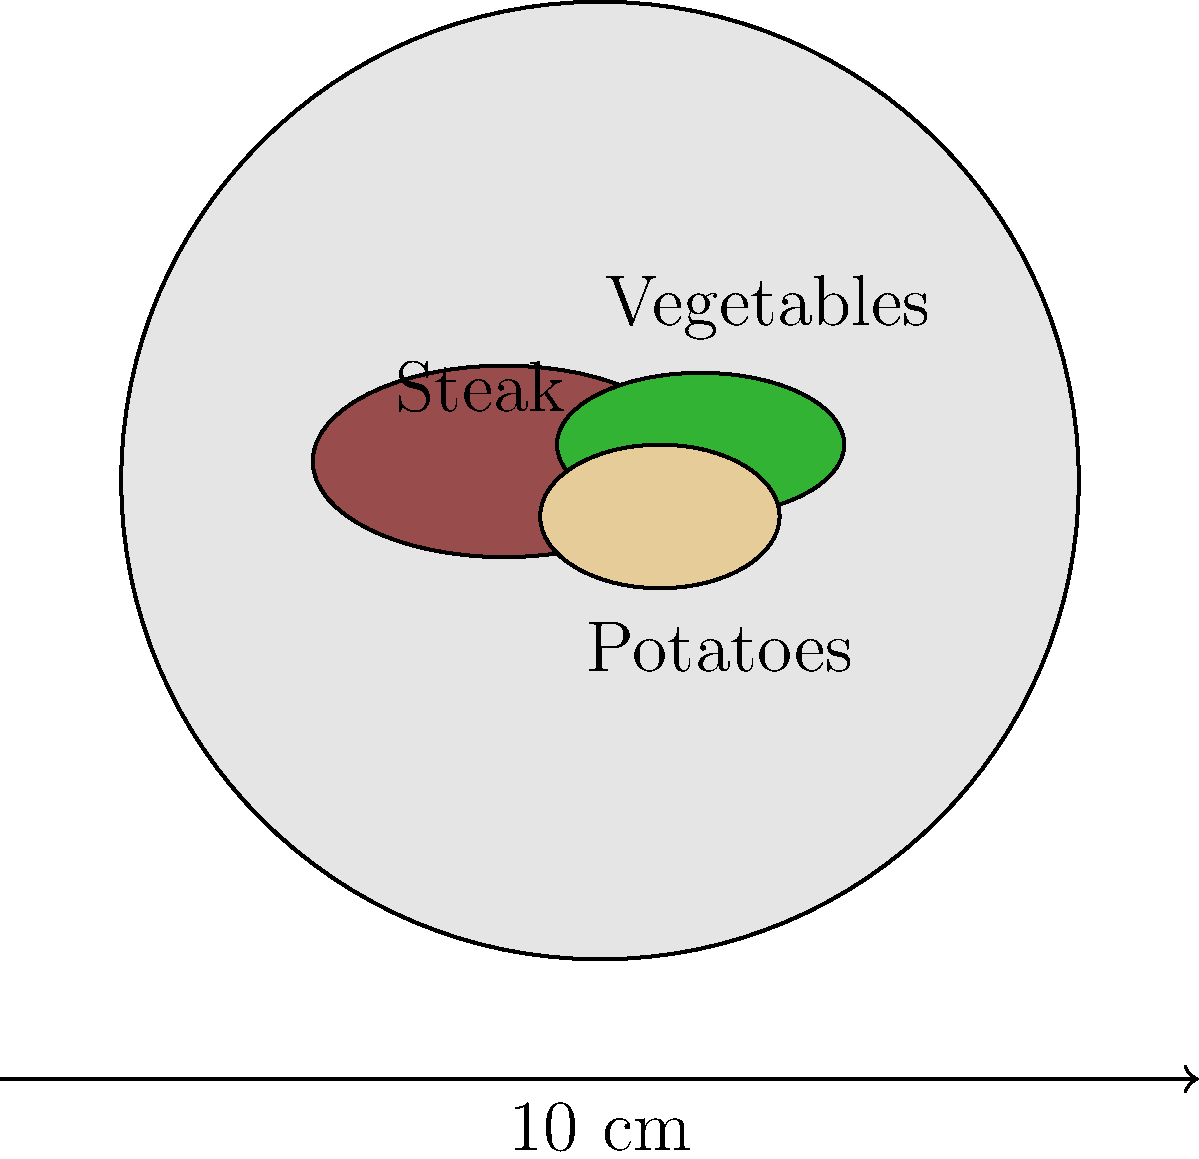As a chef, you're asked to estimate portion sizes from a photo of a plated meal. Given the image of a plate with a 10 cm diameter, estimate the approximate area (in cm²) occupied by the steak. Round your answer to the nearest whole number. To estimate the area occupied by the steak, we'll follow these steps:

1. Determine the scale of the image:
   The plate diameter is 10 cm, and in the image, it's about 4 units wide.
   So, 1 unit in the image = 10 cm / 4 = 2.5 cm in real life.

2. Estimate the dimensions of the steak:
   Length: Approximately 1.6 units * 2.5 cm/unit = 4 cm
   Width: Approximately 0.8 units * 2.5 cm/unit = 2 cm

3. Calculate the area of the steak:
   We can approximate the steak as an ellipse.
   Area of an ellipse = $\pi * a * b$, where $a$ and $b$ are the semi-major and semi-minor axes.
   
   $a = 4 \text{ cm} / 2 = 2 \text{ cm}$
   $b = 2 \text{ cm} / 2 = 1 \text{ cm}$

   Area = $\pi * 2 \text{ cm} * 1 \text{ cm} = 2\pi \text{ cm}^2$

4. Calculate the final value:
   $2\pi \text{ cm}^2 \approx 6.28 \text{ cm}^2$

5. Round to the nearest whole number:
   $6.28 \text{ cm}^2 \approx 6 \text{ cm}^2$

Therefore, the approximate area occupied by the steak is 6 cm².
Answer: 6 cm² 